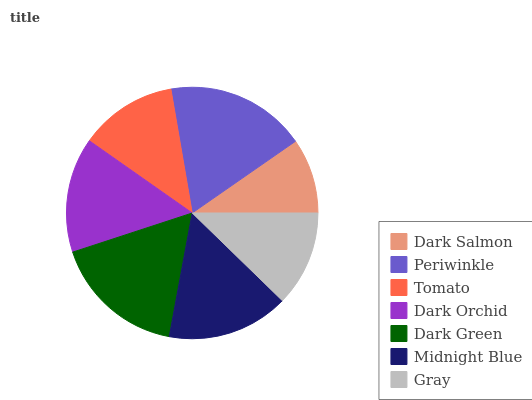Is Dark Salmon the minimum?
Answer yes or no. Yes. Is Periwinkle the maximum?
Answer yes or no. Yes. Is Tomato the minimum?
Answer yes or no. No. Is Tomato the maximum?
Answer yes or no. No. Is Periwinkle greater than Tomato?
Answer yes or no. Yes. Is Tomato less than Periwinkle?
Answer yes or no. Yes. Is Tomato greater than Periwinkle?
Answer yes or no. No. Is Periwinkle less than Tomato?
Answer yes or no. No. Is Dark Orchid the high median?
Answer yes or no. Yes. Is Dark Orchid the low median?
Answer yes or no. Yes. Is Midnight Blue the high median?
Answer yes or no. No. Is Periwinkle the low median?
Answer yes or no. No. 